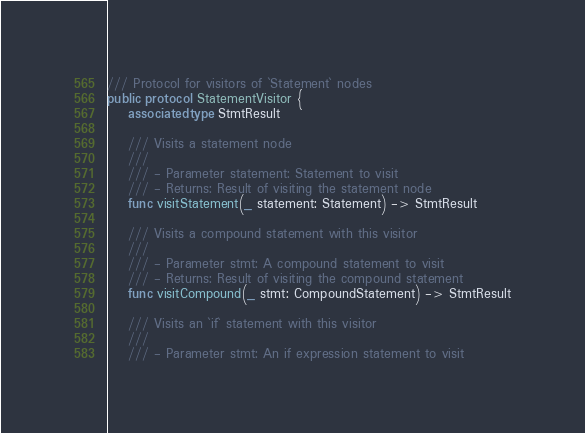<code> <loc_0><loc_0><loc_500><loc_500><_Swift_>/// Protocol for visitors of `Statement` nodes
public protocol StatementVisitor {
    associatedtype StmtResult
    
    /// Visits a statement node
    ///
    /// - Parameter statement: Statement to visit
    /// - Returns: Result of visiting the statement node
    func visitStatement(_ statement: Statement) -> StmtResult
    
    /// Visits a compound statement with this visitor
    ///
    /// - Parameter stmt: A compound statement to visit
    /// - Returns: Result of visiting the compound statement
    func visitCompound(_ stmt: CompoundStatement) -> StmtResult
    
    /// Visits an `if` statement with this visitor
    ///
    /// - Parameter stmt: An if expression statement to visit</code> 